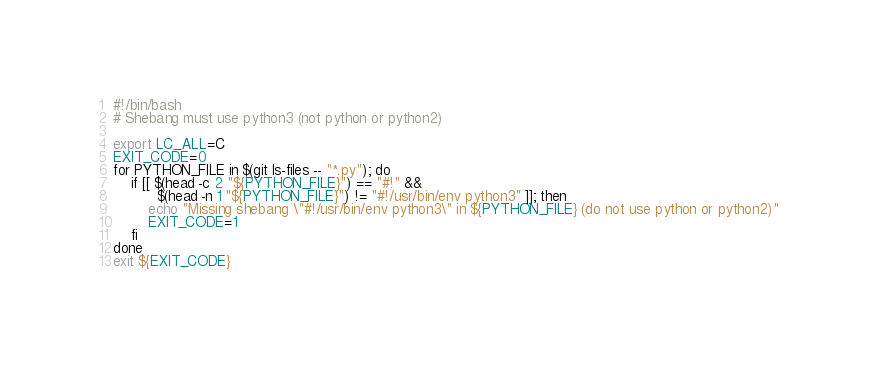<code> <loc_0><loc_0><loc_500><loc_500><_Bash_>#!/bin/bash
# Shebang must use python3 (not python or python2)

export LC_ALL=C
EXIT_CODE=0
for PYTHON_FILE in $(git ls-files -- "*.py"); do
    if [[ $(head -c 2 "${PYTHON_FILE}") == "#!" &&
          $(head -n 1 "${PYTHON_FILE}") != "#!/usr/bin/env python3" ]]; then
        echo "Missing shebang \"#!/usr/bin/env python3\" in ${PYTHON_FILE} (do not use python or python2)"
        EXIT_CODE=1
    fi
done
exit ${EXIT_CODE}
</code> 